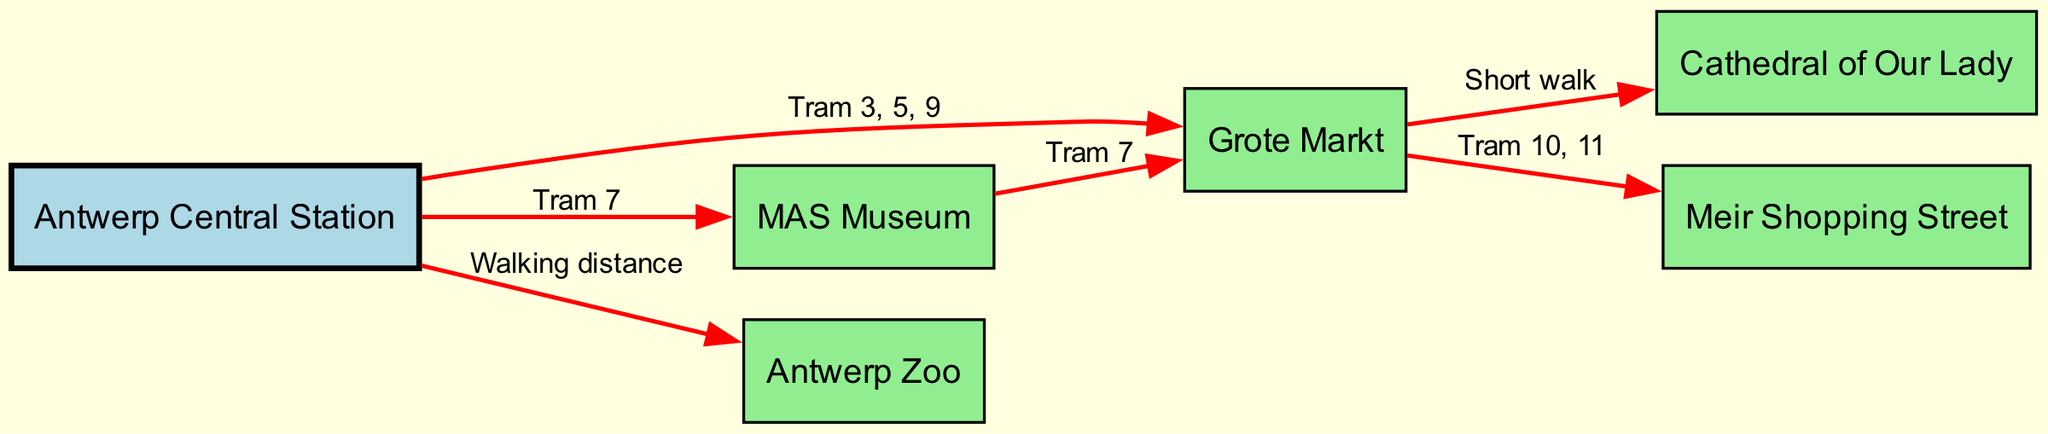What is the total number of nodes in the diagram? The diagram contains six nodes representing different locations: Antwerp Central Station, Grote Markt, MAS Museum, Antwerp Zoo, Cathedral of Our Lady, and Meir Shopping Street. Thus, counting these nodes gives a total of 6.
Answer: 6 How many tram lines connect Antwerp Central Station to other attractions? From Antwerp Central Station, there are three distinct tram lines connecting it to different attractions: Tram 3, 5, 9 to Grote Markt, Tram 7 to MAS Museum, and walking distance to Antwerp Zoo. Therefore, the count is 3.
Answer: 3 What is the connection from Grote Markt to Cathedral of Our Lady? The diagram indicates that there is a short walk from Grote Markt to Cathedral of Our Lady. This relationship is a non-tram route, which can be identified from the edges shown.
Answer: Short walk Which attraction is accessible via Tram 7? Tram 7 can be traced from the edges listed in the diagram as connecting Antwerp Central Station to the MAS Museum and from MAS Museum back to Grote Markt. Hence, the answer focuses on the MAS Museum since it's specifically named in the edges from central station.
Answer: MAS Museum What type of relationship exists between Antwerp Zoo and Antwerp Central Station? The diagram depicts a walking distance relation between Antwerp Zoo and Antwerp Central Station, indicating that it is close enough to be reached by foot rather than requiring a tram.
Answer: Walking distance Which tram numbers connect Grote Markt to Meir Shopping Street? The edge leading from Grote Markt to Meir Shopping Street indicates this connection is served by Tram 10 and Tram 11. This information can be directly pulled from the edges in the diagram.
Answer: Tram 10, 11 What color represents the transport hub in the diagram? The color for Antwerp Central Station, designated as the transport hub in the diagram, is light blue. This was established by examining the fill color assigned to its node.
Answer: Light blue How can you reach MAS Museum from Grote Markt? From the diagram, MAS Museum can be accessed from Grote Markt via Tram 7. This tram line is explicitly stated as a route in the edges connecting these two attractions.
Answer: Tram 7 